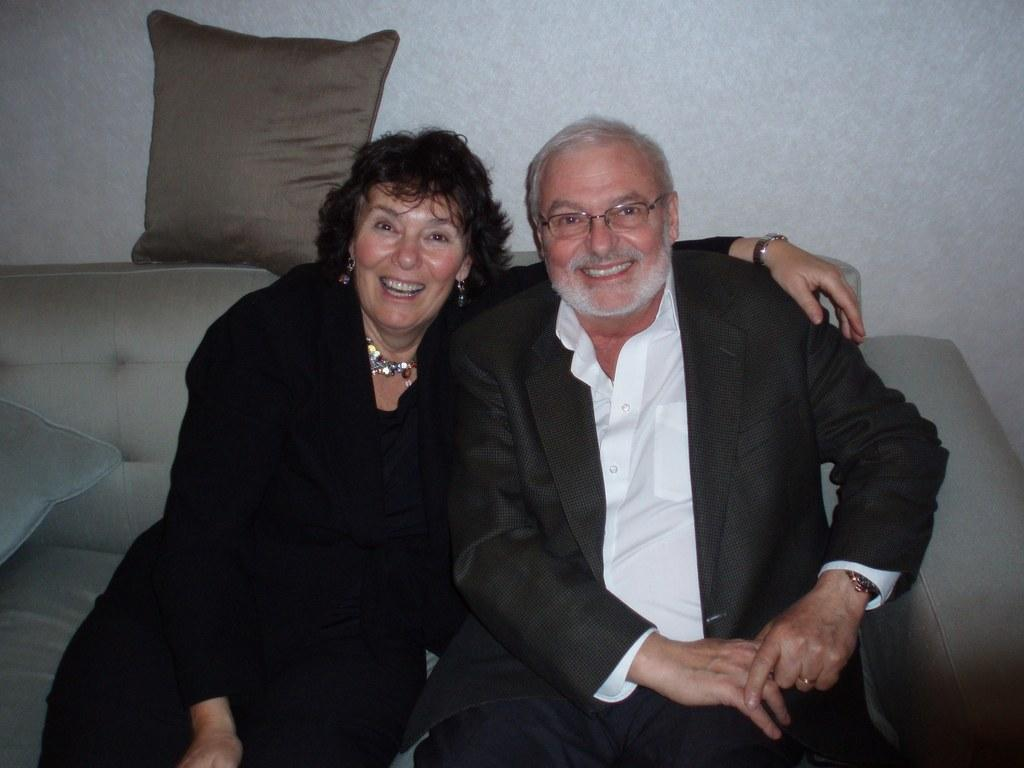How many people are in the image? There are two people in the image. What are the people doing in the image? The people are sitting on a sofa and posing for a photo. What is the emotional expression of the people in the image? The people are smiling in the image. What is located behind the people on the sofa? There is a pillow above the sofa in the image. What type of stew is being served on the sofa in the image? There is no stew present in the image; it features two people sitting on a sofa and posing for a photo. What type of wool is used to make the pillow in the image? There is no information about the type of wool used to make the pillow in the image. 